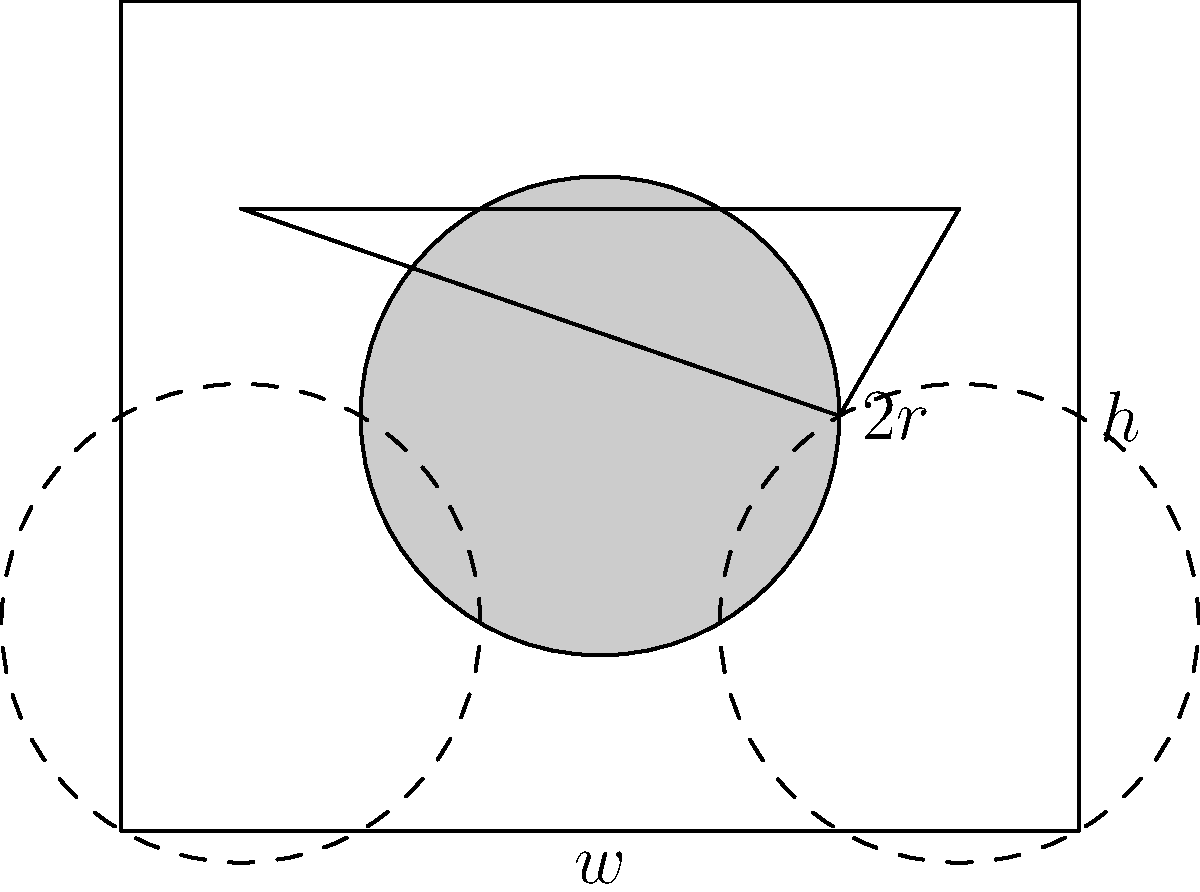Alright, booze baron, let's talk efficient storage. You've got a truckload of cylindrical beer cans to stack. If you arrange them in a hexagonal pattern like in the diagram, what's the ratio of the total area occupied by the cans to the area of the rectangular outline? Express your answer as a percentage, rounded to the nearest whole number. And remember, the more efficiently you stack, the more you can cram into your store. Let's break this down step by step:

1) In the hexagonal arrangement, each can touches six others around it.

2) The centers of three adjacent cans form an equilateral triangle. If $r$ is the radius of a can, the side length of this triangle is $2r$.

3) The height (h) of the rectangle is:
   $$h = 2r + r\sqrt{3} = r(2 + \sqrt{3})$$

4) The width (w) of the rectangle is:
   $$w = 4r$$

5) The area of the rectangle is:
   $$A_{rect} = hw = 4r^2(2 + \sqrt{3})$$

6) The area of each circular can base is:
   $$A_{can} = \pi r^2$$

7) There are two full cans and four quarter-cans in the rectangle, equivalent to three full cans.

8) The total area of cans is:
   $$A_{total cans} = 3\pi r^2$$

9) The ratio of can area to rectangle area is:
   $$\frac{A_{total cans}}{A_{rect}} = \frac{3\pi r^2}{4r^2(2 + \sqrt{3})} = \frac{3\pi}{4(2 + \sqrt{3})} \approx 0.9069$$

10) Converting to a percentage and rounding to the nearest whole number:
    $$0.9069 * 100 \approx 91\%$$
Answer: 91% 